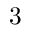Convert formula to latex. <formula><loc_0><loc_0><loc_500><loc_500>3</formula> 